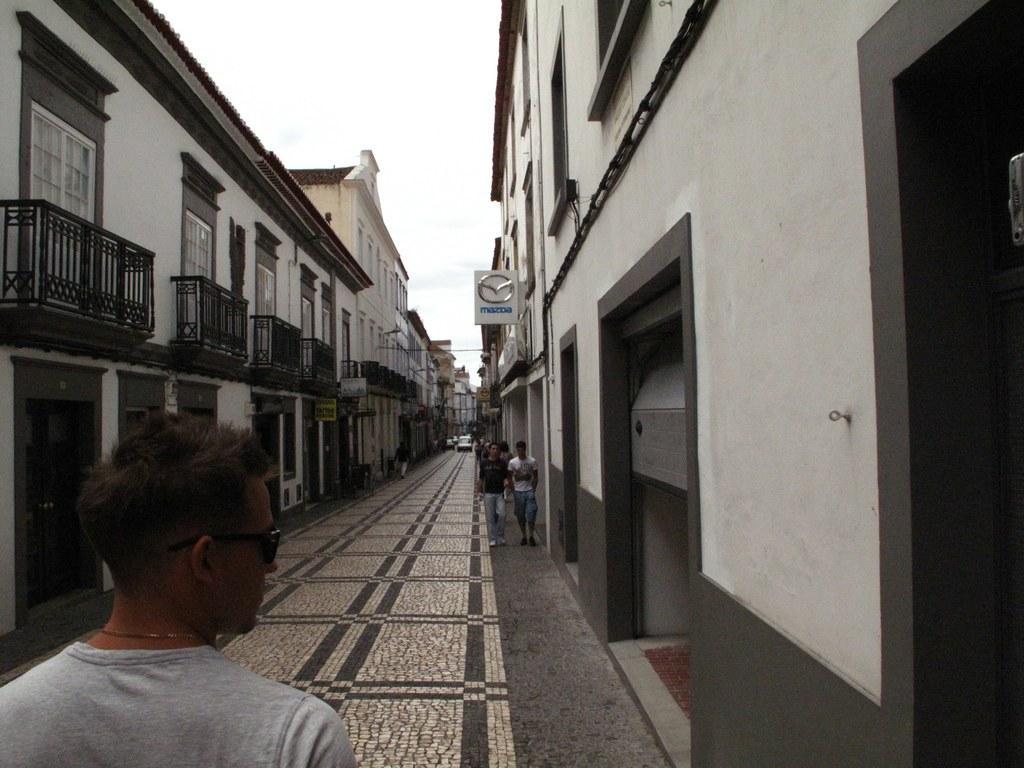In one or two sentences, can you explain what this image depicts? In this image there is a road where people are walking and cars parked, on the either side of road there are buildings. 